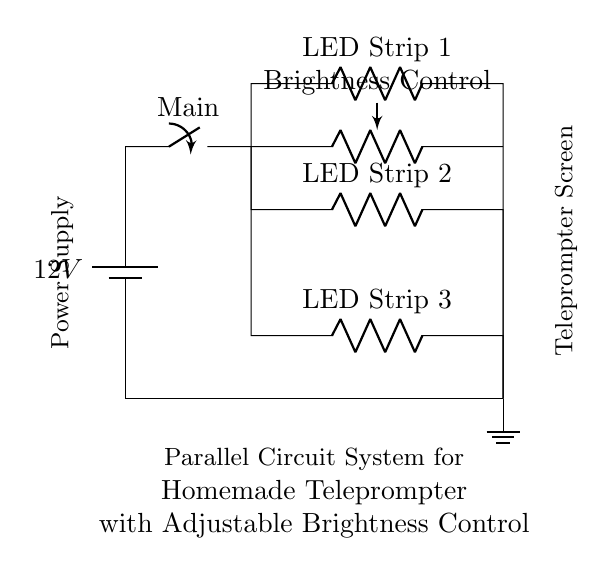What is the main power supply voltage? The circuit diagram indicates that the power supply is labeled as 12V, which can be seen at the top of the circuit representation.
Answer: 12V What does the potentiometer control? The potentiometer in the circuit is labeled as "Brightness Control," indicating its function to adjust the brightness of the connected LED strips based on resistance changes.
Answer: Brightness How many LED strips are connected in parallel? The diagram shows three parallel branches for LED strips, each denoted as LED Strip 1, LED Strip 2, and LED Strip 3.
Answer: Three What type of circuit configuration is used for the LED strips? The configuration illustrated involves multiple components connected in parallel, as indicated by the separate paths from the main voltage source to each LED strip.
Answer: Parallel How does the brightness control affect the LED strips? The potentiometer alters the resistance in the circuit, which influences the current flowing through the LED strips and thus adjusts their brightness. As the resistance changes, the current in the parallel branches will vary accordingly.
Answer: Adjusts brightness 